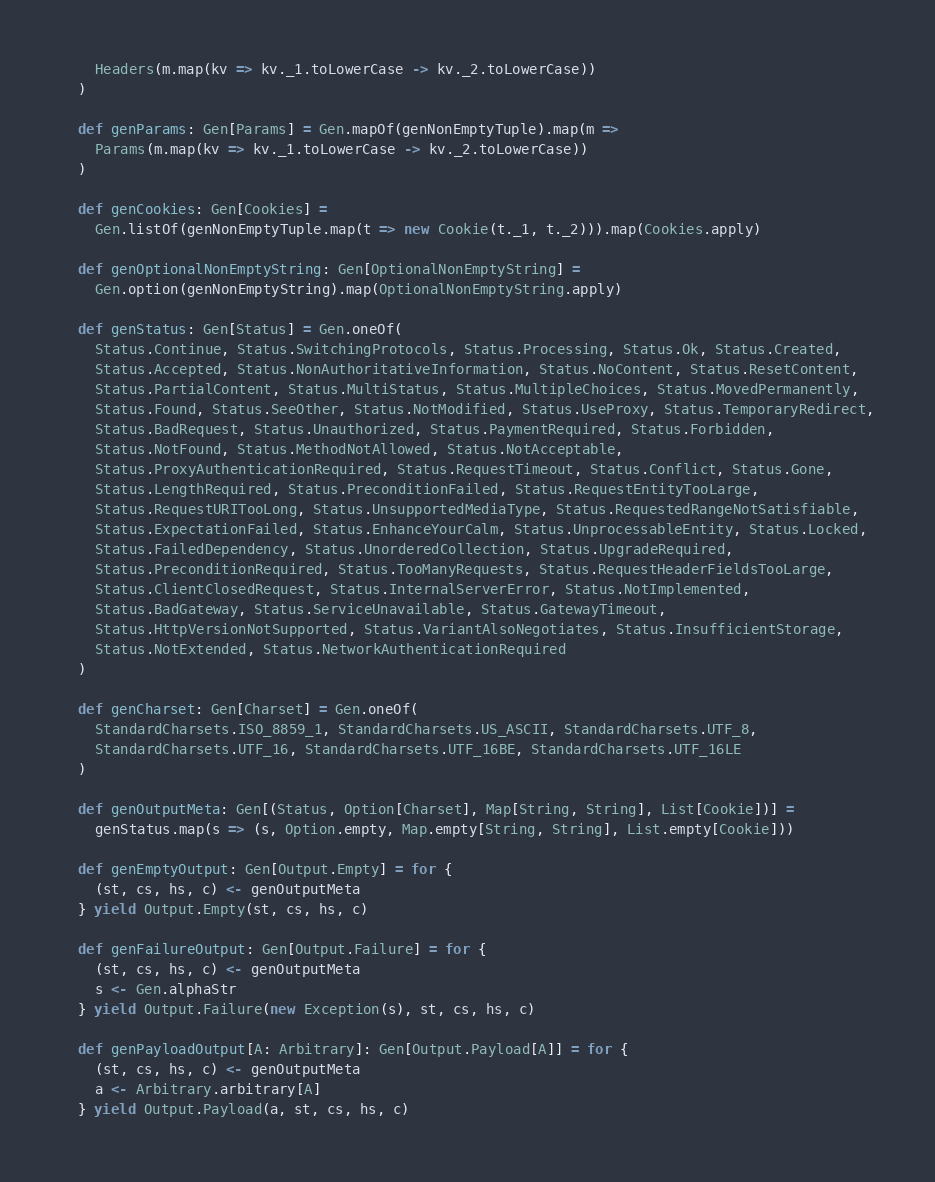Convert code to text. <code><loc_0><loc_0><loc_500><loc_500><_Scala_>    Headers(m.map(kv => kv._1.toLowerCase -> kv._2.toLowerCase))
  )

  def genParams: Gen[Params] = Gen.mapOf(genNonEmptyTuple).map(m =>
    Params(m.map(kv => kv._1.toLowerCase -> kv._2.toLowerCase))
  )

  def genCookies: Gen[Cookies] =
    Gen.listOf(genNonEmptyTuple.map(t => new Cookie(t._1, t._2))).map(Cookies.apply)

  def genOptionalNonEmptyString: Gen[OptionalNonEmptyString] =
    Gen.option(genNonEmptyString).map(OptionalNonEmptyString.apply)

  def genStatus: Gen[Status] = Gen.oneOf(
    Status.Continue, Status.SwitchingProtocols, Status.Processing, Status.Ok, Status.Created,
    Status.Accepted, Status.NonAuthoritativeInformation, Status.NoContent, Status.ResetContent,
    Status.PartialContent, Status.MultiStatus, Status.MultipleChoices, Status.MovedPermanently,
    Status.Found, Status.SeeOther, Status.NotModified, Status.UseProxy, Status.TemporaryRedirect,
    Status.BadRequest, Status.Unauthorized, Status.PaymentRequired, Status.Forbidden,
    Status.NotFound, Status.MethodNotAllowed, Status.NotAcceptable,
    Status.ProxyAuthenticationRequired, Status.RequestTimeout, Status.Conflict, Status.Gone,
    Status.LengthRequired, Status.PreconditionFailed, Status.RequestEntityTooLarge,
    Status.RequestURITooLong, Status.UnsupportedMediaType, Status.RequestedRangeNotSatisfiable,
    Status.ExpectationFailed, Status.EnhanceYourCalm, Status.UnprocessableEntity, Status.Locked,
    Status.FailedDependency, Status.UnorderedCollection, Status.UpgradeRequired,
    Status.PreconditionRequired, Status.TooManyRequests, Status.RequestHeaderFieldsTooLarge,
    Status.ClientClosedRequest, Status.InternalServerError, Status.NotImplemented,
    Status.BadGateway, Status.ServiceUnavailable, Status.GatewayTimeout,
    Status.HttpVersionNotSupported, Status.VariantAlsoNegotiates, Status.InsufficientStorage,
    Status.NotExtended, Status.NetworkAuthenticationRequired
  )

  def genCharset: Gen[Charset] = Gen.oneOf(
    StandardCharsets.ISO_8859_1, StandardCharsets.US_ASCII, StandardCharsets.UTF_8,
    StandardCharsets.UTF_16, StandardCharsets.UTF_16BE, StandardCharsets.UTF_16LE
  )

  def genOutputMeta: Gen[(Status, Option[Charset], Map[String, String], List[Cookie])] =
    genStatus.map(s => (s, Option.empty, Map.empty[String, String], List.empty[Cookie]))

  def genEmptyOutput: Gen[Output.Empty] = for {
    (st, cs, hs, c) <- genOutputMeta
  } yield Output.Empty(st, cs, hs, c)

  def genFailureOutput: Gen[Output.Failure] = for {
    (st, cs, hs, c) <- genOutputMeta
    s <- Gen.alphaStr
  } yield Output.Failure(new Exception(s), st, cs, hs, c)

  def genPayloadOutput[A: Arbitrary]: Gen[Output.Payload[A]] = for {
    (st, cs, hs, c) <- genOutputMeta
    a <- Arbitrary.arbitrary[A]
  } yield Output.Payload(a, st, cs, hs, c)
</code> 